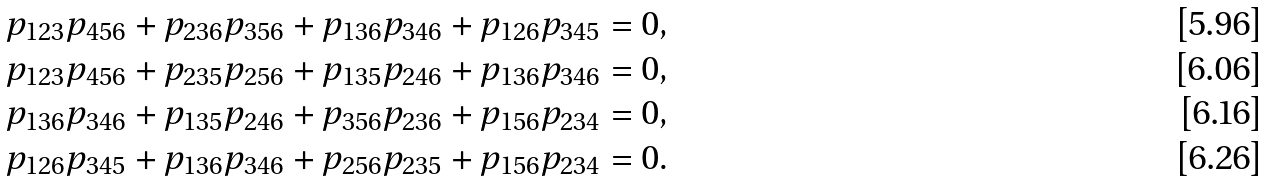<formula> <loc_0><loc_0><loc_500><loc_500>p _ { 1 2 3 } p _ { 4 5 6 } + p _ { 2 3 6 } p _ { 3 5 6 } + p _ { 1 3 6 } p _ { 3 4 6 } + p _ { 1 2 6 } p _ { 3 4 5 } = 0 , \\ p _ { 1 2 3 } p _ { 4 5 6 } + p _ { 2 3 5 } p _ { 2 5 6 } + p _ { 1 3 5 } p _ { 2 4 6 } + p _ { 1 3 6 } p _ { 3 4 6 } = 0 , \\ p _ { 1 3 6 } p _ { 3 4 6 } + p _ { 1 3 5 } p _ { 2 4 6 } + p _ { 3 5 6 } p _ { 2 3 6 } + p _ { 1 5 6 } p _ { 2 3 4 } = 0 , \\ p _ { 1 2 6 } p _ { 3 4 5 } + p _ { 1 3 6 } p _ { 3 4 6 } + p _ { 2 5 6 } p _ { 2 3 5 } + p _ { 1 5 6 } p _ { 2 3 4 } = 0 .</formula> 